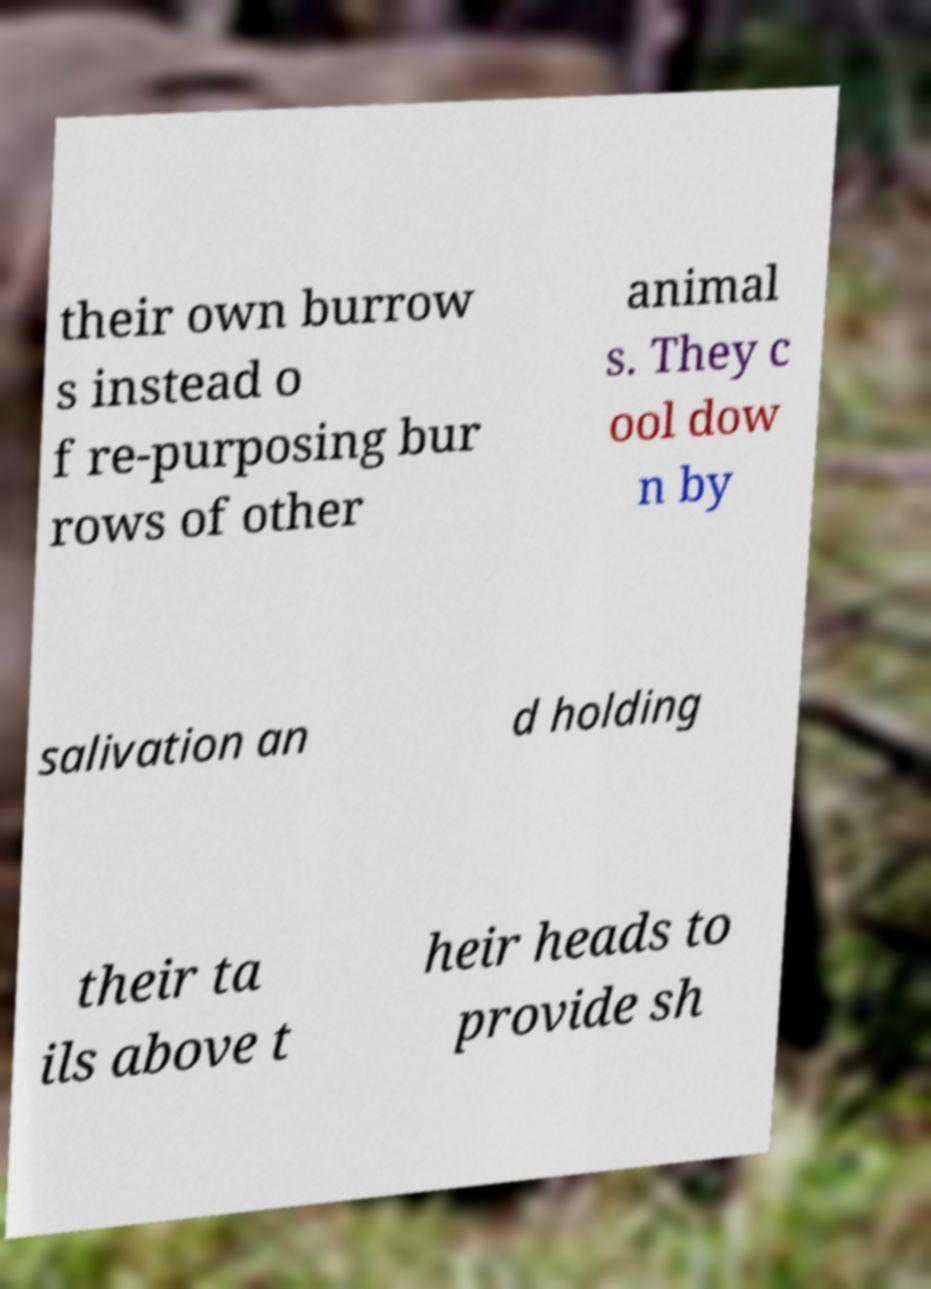Could you assist in decoding the text presented in this image and type it out clearly? their own burrow s instead o f re-purposing bur rows of other animal s. They c ool dow n by salivation an d holding their ta ils above t heir heads to provide sh 